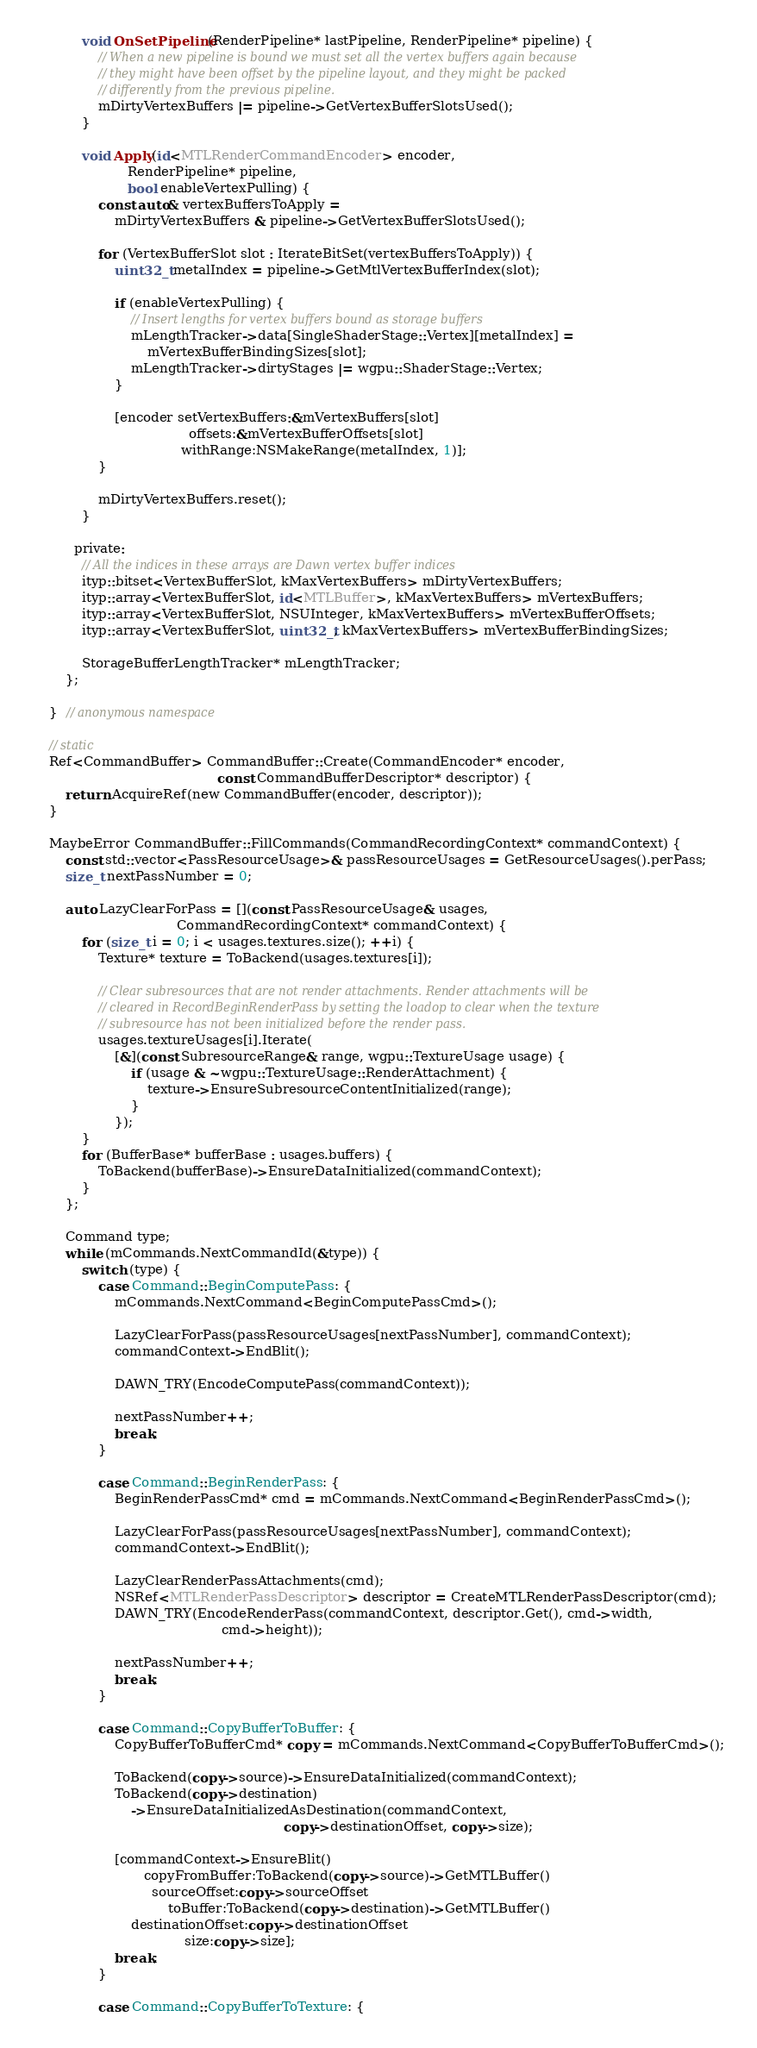Convert code to text. <code><loc_0><loc_0><loc_500><loc_500><_ObjectiveC_>
            void OnSetPipeline(RenderPipeline* lastPipeline, RenderPipeline* pipeline) {
                // When a new pipeline is bound we must set all the vertex buffers again because
                // they might have been offset by the pipeline layout, and they might be packed
                // differently from the previous pipeline.
                mDirtyVertexBuffers |= pipeline->GetVertexBufferSlotsUsed();
            }

            void Apply(id<MTLRenderCommandEncoder> encoder,
                       RenderPipeline* pipeline,
                       bool enableVertexPulling) {
                const auto& vertexBuffersToApply =
                    mDirtyVertexBuffers & pipeline->GetVertexBufferSlotsUsed();

                for (VertexBufferSlot slot : IterateBitSet(vertexBuffersToApply)) {
                    uint32_t metalIndex = pipeline->GetMtlVertexBufferIndex(slot);

                    if (enableVertexPulling) {
                        // Insert lengths for vertex buffers bound as storage buffers
                        mLengthTracker->data[SingleShaderStage::Vertex][metalIndex] =
                            mVertexBufferBindingSizes[slot];
                        mLengthTracker->dirtyStages |= wgpu::ShaderStage::Vertex;
                    }

                    [encoder setVertexBuffers:&mVertexBuffers[slot]
                                      offsets:&mVertexBufferOffsets[slot]
                                    withRange:NSMakeRange(metalIndex, 1)];
                }

                mDirtyVertexBuffers.reset();
            }

          private:
            // All the indices in these arrays are Dawn vertex buffer indices
            ityp::bitset<VertexBufferSlot, kMaxVertexBuffers> mDirtyVertexBuffers;
            ityp::array<VertexBufferSlot, id<MTLBuffer>, kMaxVertexBuffers> mVertexBuffers;
            ityp::array<VertexBufferSlot, NSUInteger, kMaxVertexBuffers> mVertexBufferOffsets;
            ityp::array<VertexBufferSlot, uint32_t, kMaxVertexBuffers> mVertexBufferBindingSizes;

            StorageBufferLengthTracker* mLengthTracker;
        };

    }  // anonymous namespace

    // static
    Ref<CommandBuffer> CommandBuffer::Create(CommandEncoder* encoder,
                                             const CommandBufferDescriptor* descriptor) {
        return AcquireRef(new CommandBuffer(encoder, descriptor));
    }

    MaybeError CommandBuffer::FillCommands(CommandRecordingContext* commandContext) {
        const std::vector<PassResourceUsage>& passResourceUsages = GetResourceUsages().perPass;
        size_t nextPassNumber = 0;

        auto LazyClearForPass = [](const PassResourceUsage& usages,
                                   CommandRecordingContext* commandContext) {
            for (size_t i = 0; i < usages.textures.size(); ++i) {
                Texture* texture = ToBackend(usages.textures[i]);

                // Clear subresources that are not render attachments. Render attachments will be
                // cleared in RecordBeginRenderPass by setting the loadop to clear when the texture
                // subresource has not been initialized before the render pass.
                usages.textureUsages[i].Iterate(
                    [&](const SubresourceRange& range, wgpu::TextureUsage usage) {
                        if (usage & ~wgpu::TextureUsage::RenderAttachment) {
                            texture->EnsureSubresourceContentInitialized(range);
                        }
                    });
            }
            for (BufferBase* bufferBase : usages.buffers) {
                ToBackend(bufferBase)->EnsureDataInitialized(commandContext);
            }
        };

        Command type;
        while (mCommands.NextCommandId(&type)) {
            switch (type) {
                case Command::BeginComputePass: {
                    mCommands.NextCommand<BeginComputePassCmd>();

                    LazyClearForPass(passResourceUsages[nextPassNumber], commandContext);
                    commandContext->EndBlit();

                    DAWN_TRY(EncodeComputePass(commandContext));

                    nextPassNumber++;
                    break;
                }

                case Command::BeginRenderPass: {
                    BeginRenderPassCmd* cmd = mCommands.NextCommand<BeginRenderPassCmd>();

                    LazyClearForPass(passResourceUsages[nextPassNumber], commandContext);
                    commandContext->EndBlit();

                    LazyClearRenderPassAttachments(cmd);
                    NSRef<MTLRenderPassDescriptor> descriptor = CreateMTLRenderPassDescriptor(cmd);
                    DAWN_TRY(EncodeRenderPass(commandContext, descriptor.Get(), cmd->width,
                                              cmd->height));

                    nextPassNumber++;
                    break;
                }

                case Command::CopyBufferToBuffer: {
                    CopyBufferToBufferCmd* copy = mCommands.NextCommand<CopyBufferToBufferCmd>();

                    ToBackend(copy->source)->EnsureDataInitialized(commandContext);
                    ToBackend(copy->destination)
                        ->EnsureDataInitializedAsDestination(commandContext,
                                                             copy->destinationOffset, copy->size);

                    [commandContext->EnsureBlit()
                           copyFromBuffer:ToBackend(copy->source)->GetMTLBuffer()
                             sourceOffset:copy->sourceOffset
                                 toBuffer:ToBackend(copy->destination)->GetMTLBuffer()
                        destinationOffset:copy->destinationOffset
                                     size:copy->size];
                    break;
                }

                case Command::CopyBufferToTexture: {</code> 